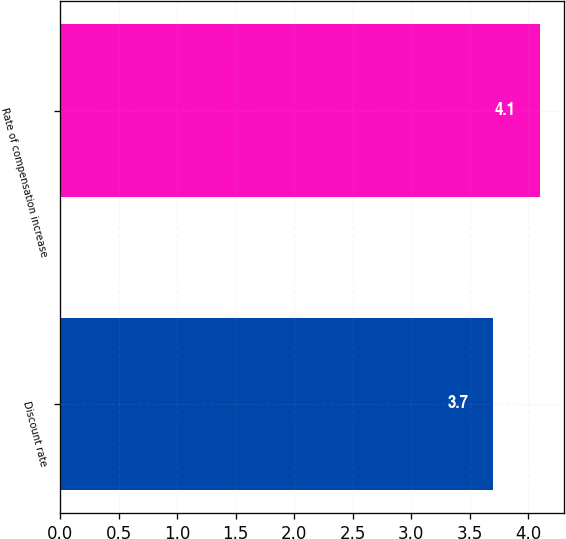Convert chart to OTSL. <chart><loc_0><loc_0><loc_500><loc_500><bar_chart><fcel>Discount rate<fcel>Rate of compensation increase<nl><fcel>3.7<fcel>4.1<nl></chart> 